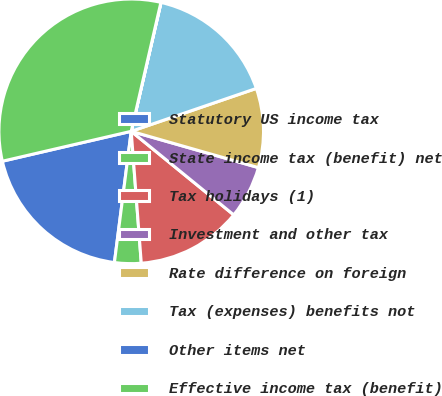<chart> <loc_0><loc_0><loc_500><loc_500><pie_chart><fcel>Statutory US income tax<fcel>State income tax (benefit) net<fcel>Tax holidays (1)<fcel>Investment and other tax<fcel>Rate difference on foreign<fcel>Tax (expenses) benefits not<fcel>Other items net<fcel>Effective income tax (benefit)<nl><fcel>19.34%<fcel>3.24%<fcel>12.9%<fcel>6.46%<fcel>9.68%<fcel>16.12%<fcel>0.02%<fcel>32.23%<nl></chart> 